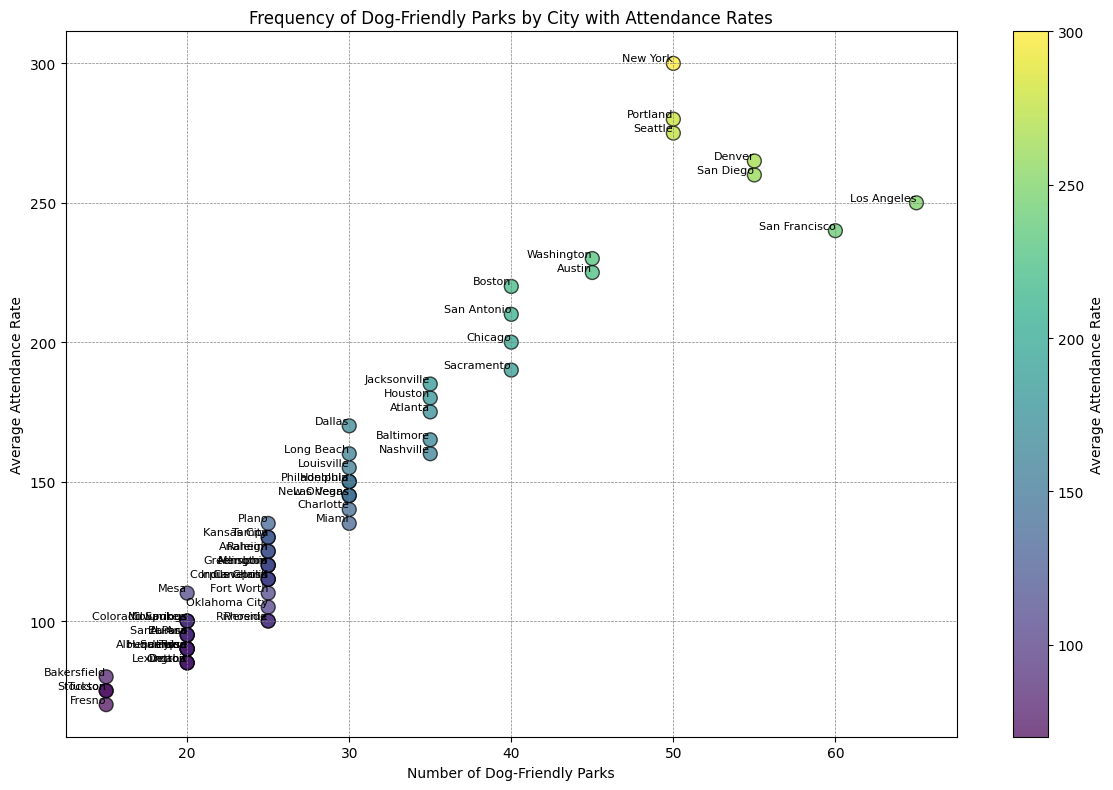What is the highest average attendance rate among the cities? To find the highest average attendance rate, look for the point located at the greatest y-axis value. The y-axis represents the average attendance rate. The city at this highest point is Portland, with an attendance rate of 280.
Answer: Portland, 280 Which two cities have the same number of dog-friendly parks but different average attendance rates? To find cities with the same number of parks but different attendance rates, locate points with the same x-coordinate (Number of Dog-Friendly Parks) but different y-coordinates (Average Attendance Rate). For example, Chicago and San Antonio both have 40 parks but different attendance rates of 200 and 210, respectively.
Answer: Chicago and San Antonio What city has the lowest average attendance rate, and how many dog-friendly parks does it have? Look for the point located at the smallest y-axis value which represents the average attendance rate. The city at this point is Detroit, with an attendance rate of 85. The x-axis shows the number of parks as 20.
Answer: Detroit, 20 Which city has the most dog-friendly parks, and what is its average attendance rate? The city with the most parks will be at the rightmost point on the x-axis. This city is Los Angeles with 65 parks. The y-axis shows its average attendance rate as 250.
Answer: Los Angeles, 250 Does any city with 25 dog-friendly parks have an average attendance rate higher than 200? To answer this, locate points with an x-coordinate of 25 and check if any have a y-coordinate greater than 200. None of the cities with 25 parks have an attendance rate exceeding 200.
Answer: No How many cities have an average attendance rate below 100? Count the number of points with a y-coordinate less than 100. The cities matching this criterion are San Jose, Detroit, El Paso, Omaha, and Fresno.
Answer: 5 Which city has a higher attendance rate, Denver or Austin? Find the points representing Denver and Austin. Denver has an attendance rate of 265, and Austin has an attendance rate of 225. Comparing these, Denver has a higher attendance rate.
Answer: Denver What is the average attendance rate for cities with 30 dog-friendly parks? Locate the points with 30 dog-friendly parks and calculate their average attendance rate. The cities are Philadelphia (150), Dallas (170), Charlotte (140), Las Vegas (145), Louisville (155), Miami (135), New Orleans (145), and Honolulu (150). The total of these values is 1190. Dividing by 8 gives an average attendance rate of 148.75.
Answer: 148.75 Which city has the closest to the median number of dog-friendly parks and what is its average attendance rate? The cities should be sorted by the number of dog-friendly parks. With 51 data points, the median is the 26th data point. The city at the median is Albuquerque with 20 parks, and its average attendance rate is 90.
Answer: Albuquerque, 90 How many cities have exactly 20 dog-friendly parks, and what are their average attendance rates? Count the points with an x-coordinate of 20 and list their y-coordinates. The cities with 20 parks are San Jose (90), Columbus (100), Detroit (85), Milwaukee (100), Albuquerque (90), Colorado Springs (100), Omaha (85), Tulsa (90), and Lexington (85).
Answer: 9 cities: San Jose (90), Columbus (100), Detroit (85), Milwaukee (100), Albuquerque (90), Colorado Springs (100), Omaha (85), Tulsa (90), Lexington (85) 